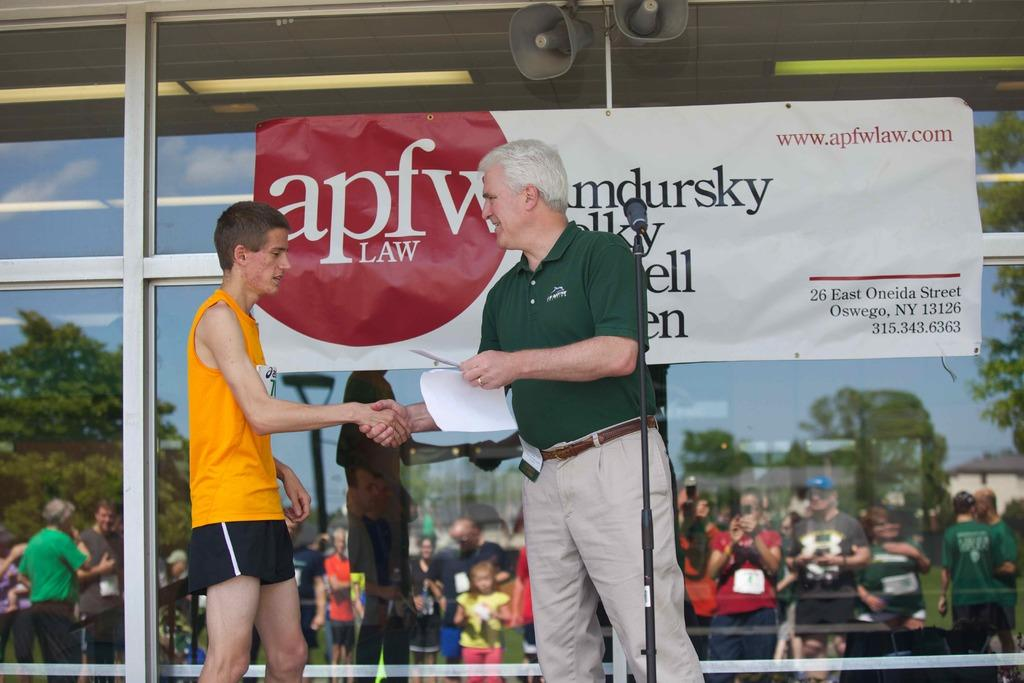<image>
Give a short and clear explanation of the subsequent image. A banner has a apfw law logo and hangs on a window. 